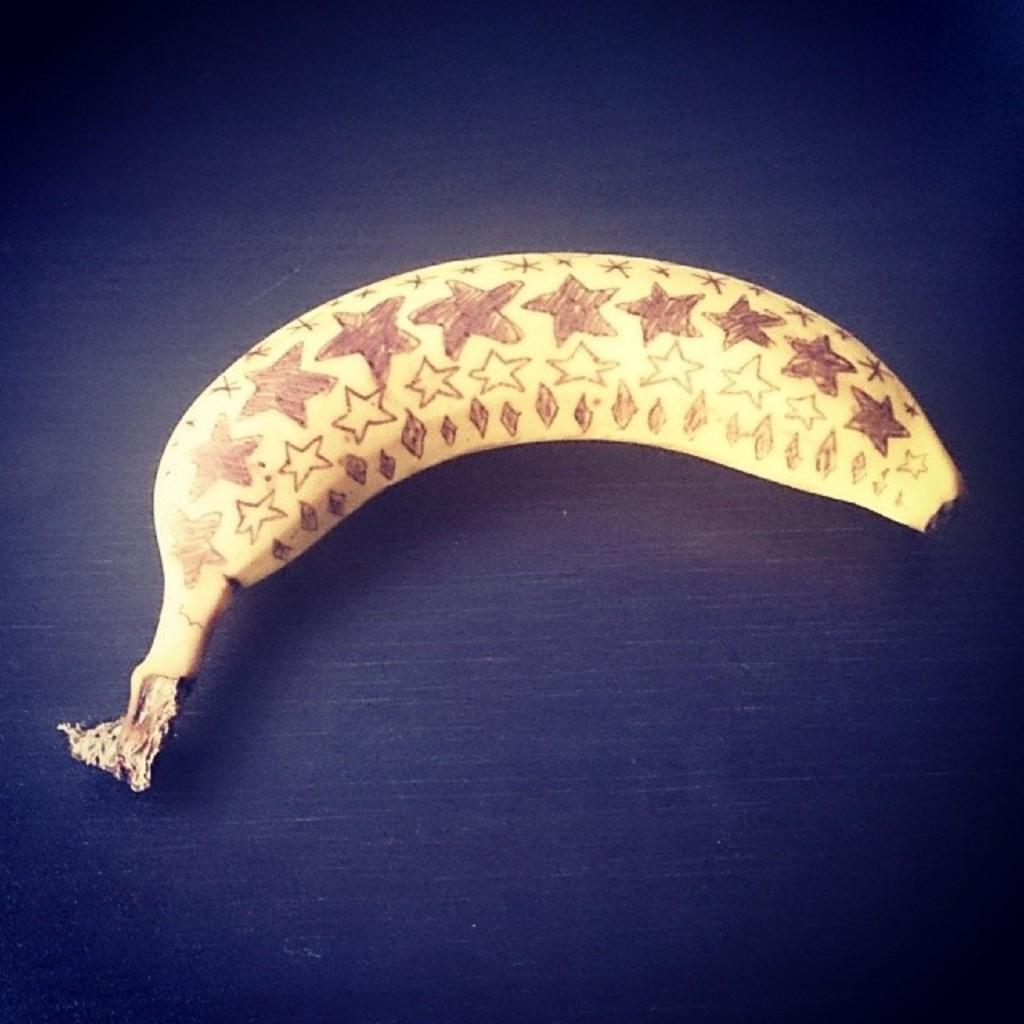What fruit is present in the image? There is a banana in the image. What is the color of the surface on which the banana is placed? The banana is on a black surface. What type of harmony can be heard in the background of the image? There is no audible harmony in the image, as it is a still image of a banana on a black surface. 